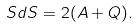Convert formula to latex. <formula><loc_0><loc_0><loc_500><loc_500>S d S = 2 ( A + Q ) .</formula> 